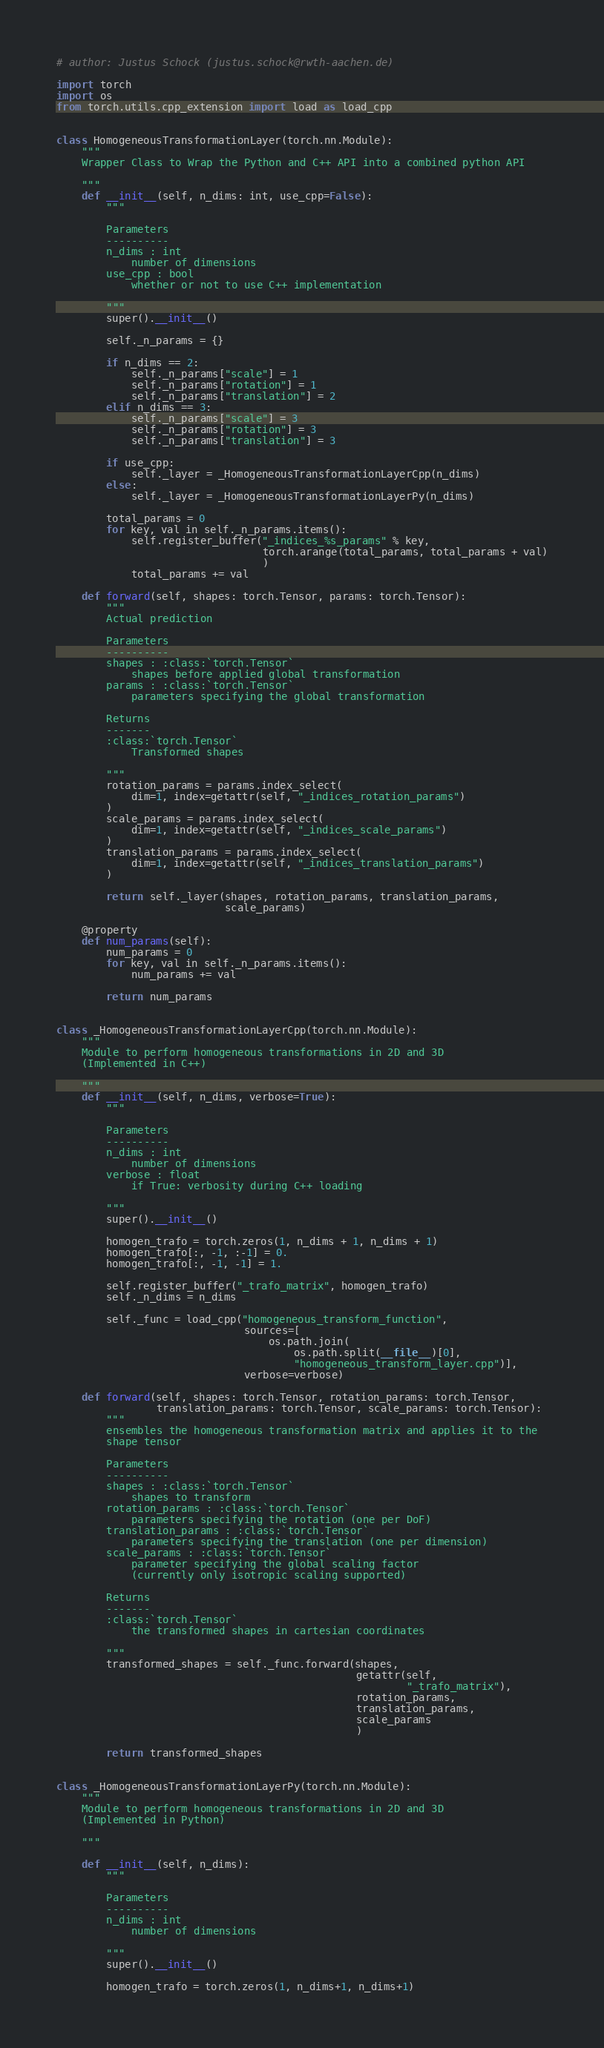<code> <loc_0><loc_0><loc_500><loc_500><_Python_># author: Justus Schock (justus.schock@rwth-aachen.de)

import torch
import os
from torch.utils.cpp_extension import load as load_cpp


class HomogeneousTransformationLayer(torch.nn.Module):
    """
    Wrapper Class to Wrap the Python and C++ API into a combined python API

    """
    def __init__(self, n_dims: int, use_cpp=False):
        """

        Parameters
        ----------
        n_dims : int
            number of dimensions
        use_cpp : bool
            whether or not to use C++ implementation

        """
        super().__init__()

        self._n_params = {}

        if n_dims == 2:
            self._n_params["scale"] = 1
            self._n_params["rotation"] = 1
            self._n_params["translation"] = 2
        elif n_dims == 3:
            self._n_params["scale"] = 3
            self._n_params["rotation"] = 3
            self._n_params["translation"] = 3

        if use_cpp:
            self._layer = _HomogeneousTransformationLayerCpp(n_dims)
        else:
            self._layer = _HomogeneousTransformationLayerPy(n_dims)

        total_params = 0
        for key, val in self._n_params.items():
            self.register_buffer("_indices_%s_params" % key,
                                 torch.arange(total_params, total_params + val)
                                 )
            total_params += val

    def forward(self, shapes: torch.Tensor, params: torch.Tensor):
        """
        Actual prediction

        Parameters
        ----------
        shapes : :class:`torch.Tensor`
            shapes before applied global transformation
        params : :class:`torch.Tensor`
            parameters specifying the global transformation

        Returns
        -------
        :class:`torch.Tensor`
            Transformed shapes

        """
        rotation_params = params.index_select(
            dim=1, index=getattr(self, "_indices_rotation_params")
        )
        scale_params = params.index_select(
            dim=1, index=getattr(self, "_indices_scale_params")
        )
        translation_params = params.index_select(
            dim=1, index=getattr(self, "_indices_translation_params")
        )

        return self._layer(shapes, rotation_params, translation_params,
                           scale_params)

    @property
    def num_params(self):
        num_params = 0
        for key, val in self._n_params.items():
            num_params += val

        return num_params


class _HomogeneousTransformationLayerCpp(torch.nn.Module):
    """
    Module to perform homogeneous transformations in 2D and 3D
    (Implemented in C++)

    """
    def __init__(self, n_dims, verbose=True):
        """

        Parameters
        ----------
        n_dims : int
            number of dimensions
        verbose : float
            if True: verbosity during C++ loading

        """
        super().__init__()

        homogen_trafo = torch.zeros(1, n_dims + 1, n_dims + 1)
        homogen_trafo[:, -1, :-1] = 0.
        homogen_trafo[:, -1, -1] = 1.

        self.register_buffer("_trafo_matrix", homogen_trafo)
        self._n_dims = n_dims

        self._func = load_cpp("homogeneous_transform_function",
                              sources=[
                                  os.path.join(
                                      os.path.split(__file__)[0],
                                      "homogeneous_transform_layer.cpp")],
                              verbose=verbose)

    def forward(self, shapes: torch.Tensor, rotation_params: torch.Tensor,
                translation_params: torch.Tensor, scale_params: torch.Tensor):
        """
        ensembles the homogeneous transformation matrix and applies it to the
        shape tensor

        Parameters
        ----------
        shapes : :class:`torch.Tensor`
            shapes to transform
        rotation_params : :class:`torch.Tensor`
            parameters specifying the rotation (one per DoF)
        translation_params : :class:`torch.Tensor`
            parameters specifying the translation (one per dimension)
        scale_params : :class:`torch.Tensor`
            parameter specifying the global scaling factor
            (currently only isotropic scaling supported)

        Returns
        -------
        :class:`torch.Tensor`
            the transformed shapes in cartesian coordinates

        """
        transformed_shapes = self._func.forward(shapes,
                                                getattr(self,
                                                        "_trafo_matrix"),
                                                rotation_params,
                                                translation_params,
                                                scale_params
                                                )

        return transformed_shapes


class _HomogeneousTransformationLayerPy(torch.nn.Module):
    """
    Module to perform homogeneous transformations in 2D and 3D
    (Implemented in Python)

    """

    def __init__(self, n_dims):
        """

        Parameters
        ----------
        n_dims : int
            number of dimensions

        """
        super().__init__()

        homogen_trafo = torch.zeros(1, n_dims+1, n_dims+1)</code> 